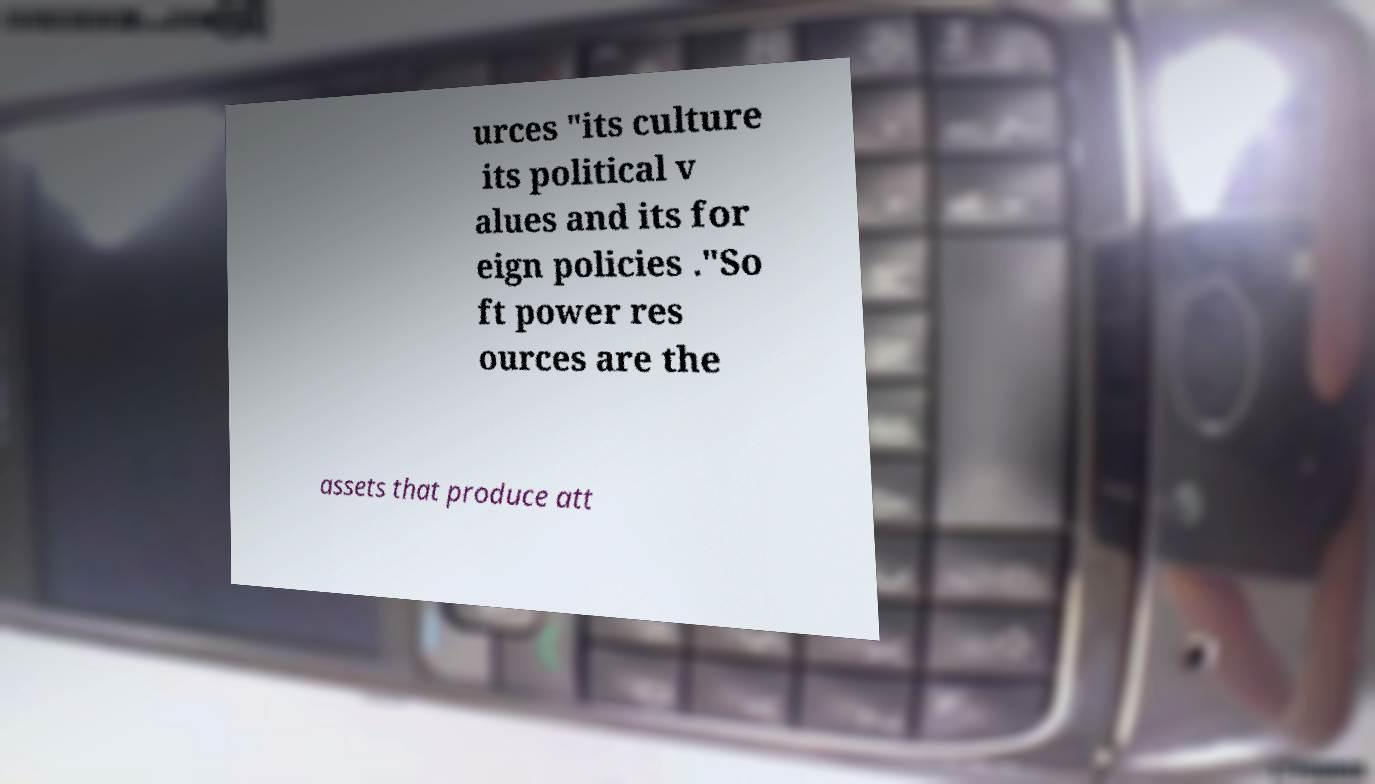Please read and relay the text visible in this image. What does it say? urces "its culture its political v alues and its for eign policies ."So ft power res ources are the assets that produce att 